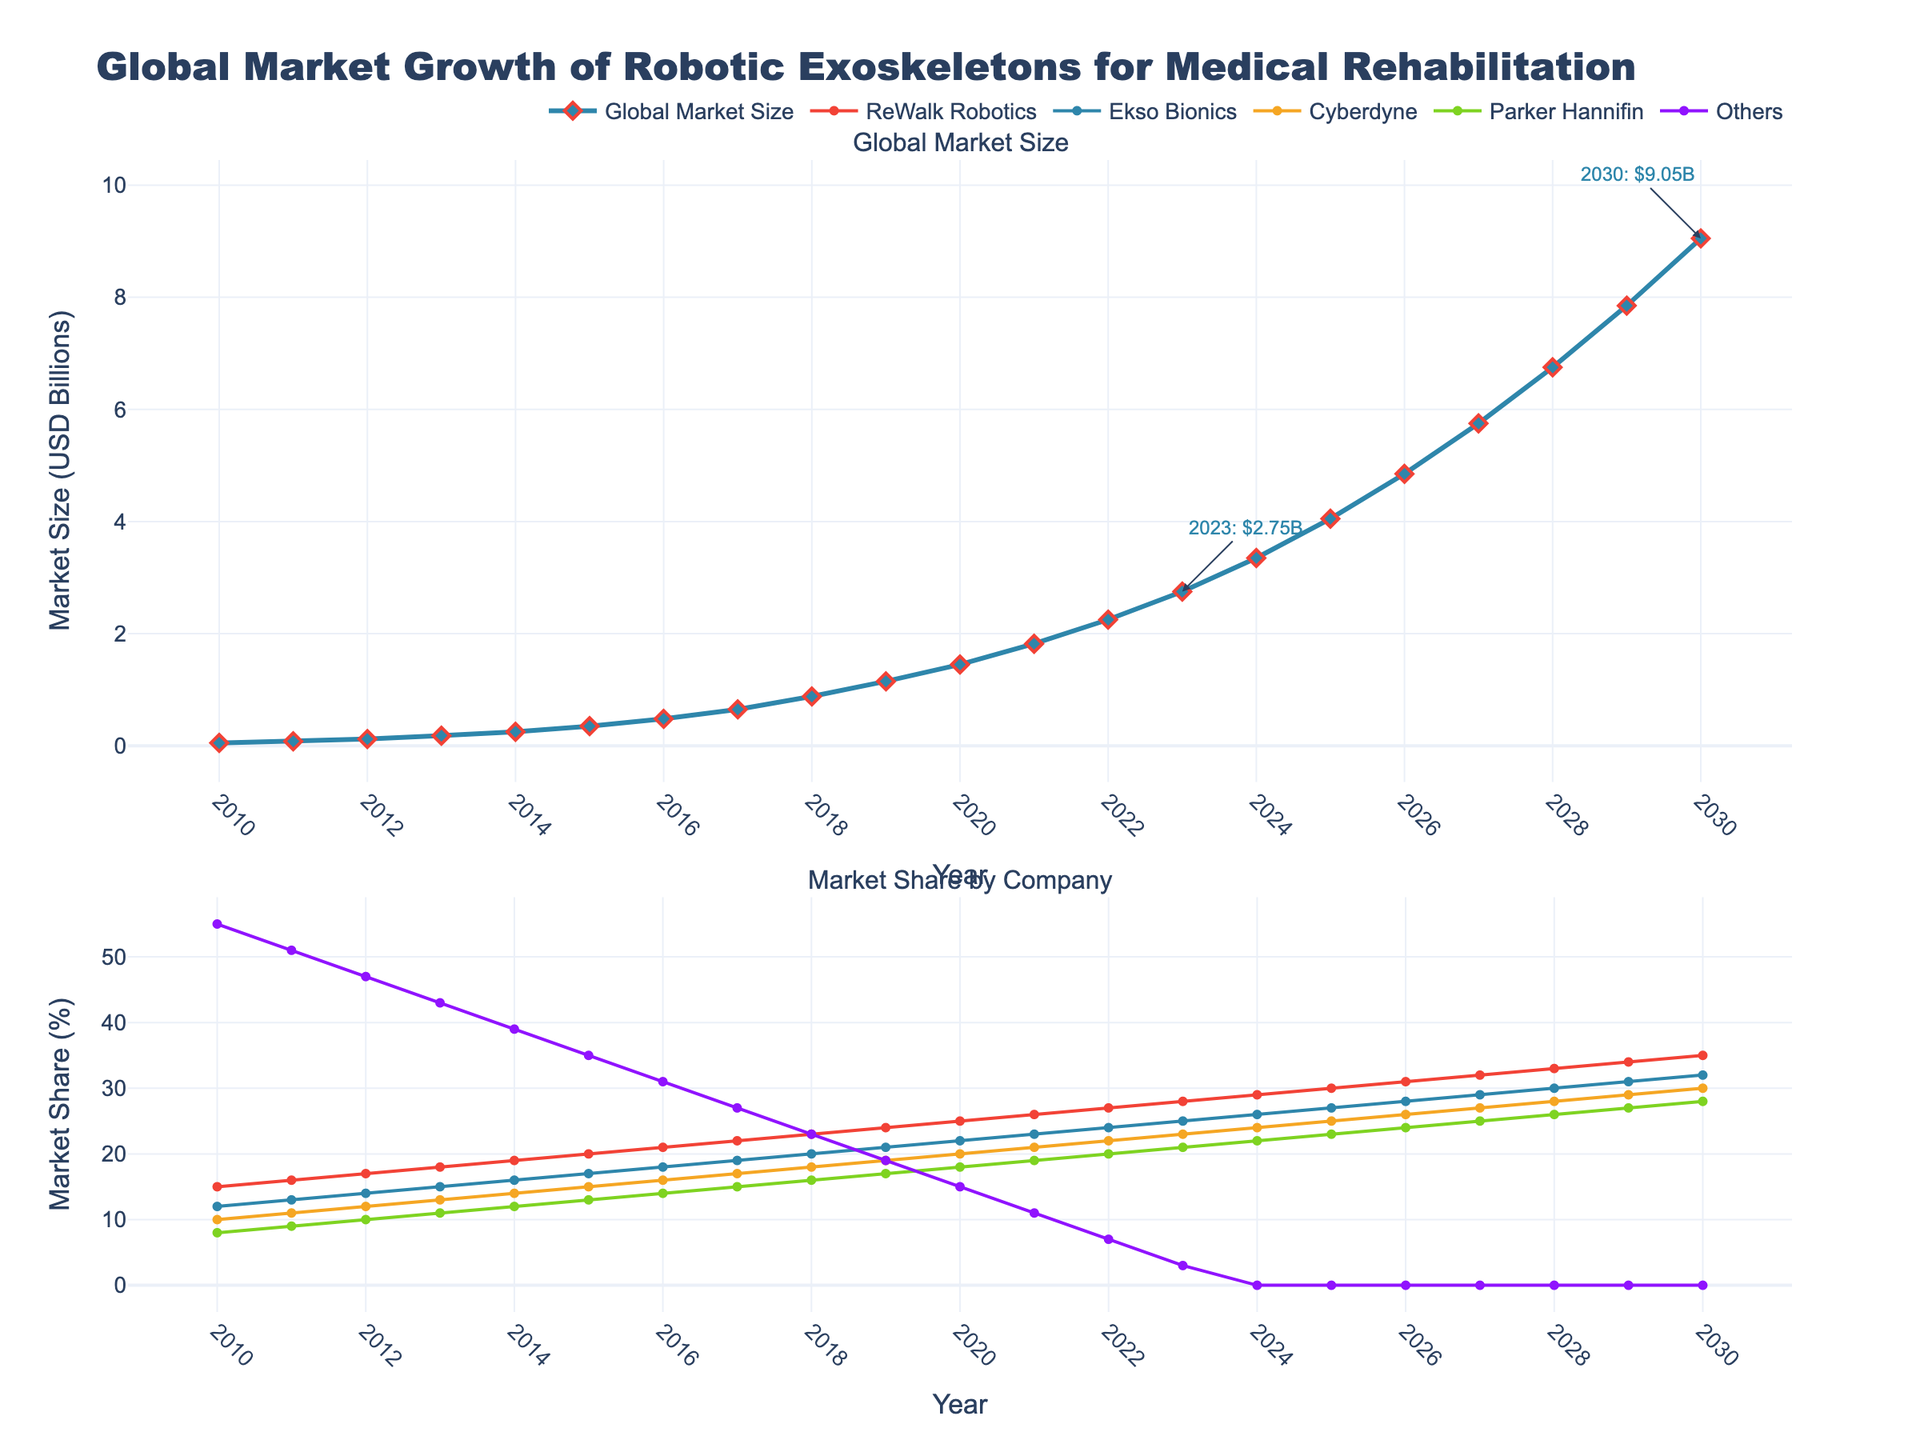What is the total market share of ReWalk Robotics and Cyberdyne in 2025? ReWalk Robotics has a market share of 30% and Cyberdyne has a market share of 25% in 2025. Summing these gives 30% + 25% = 55%
Answer: 55% Which company has the highest market share in 2020? In 2020, ReWalk Robotics has the highest market share at 25%, as it's the highest value among the companies listed for that year.
Answer: ReWalk Robotics How much did the global market size increase from 2010 to 2023? The market size in 2010 was 0.05 billion USD and in 2023 it was 2.75 billion USD. The increase is 2.75 - 0.05 = 2.70 billion USD.
Answer: 2.70 billion USD Compare the market share of Parker Hannifin in 2013 and 2023? In 2013, Parker Hannifin had a market share of 11%, and in 2023, the share increased to 21%. The increase is 21% - 11% = 10%.
Answer: Parker Hannifin's market share increased by 10% What is the trend in market share for Ekso Bionics from 2010 to 2023? Ekso Bionics' market share has shown a continuous increase from 12% in 2010 to 25% in 2023. This indicates a consistent growth trend over the years.
Answer: Consistent growth By how much does the global market size forecast for 2030 exceed the forecast for 2025? The forecasted market size for 2030 is 9.05 billion USD, while for 2025 it is 4.05 billion USD. The difference is 9.05 - 4.05 = 5 billion USD.
Answer: 5 billion USD What is the average annual growth rate of the global market size from 2020 to 2023? The global market size grows from 1.45 billion USD in 2020 to 2.75 billion USD in 2023, which is over 3 years. The growth rate can be approximated as (2.75 - 1.45) / 3 = 0.433 billion USD per year.
Answer: 0.433 billion USD per year How does the market share of "Others" change from 2010 to 2023? The market share of "Others" declines from 55% in 2010 to 3% in 2023, showing a significant decrease over the years.
Answer: Significant decrease Which company shows the second-highest market share in 2012? In 2012, Ekso Bionics shows the second-highest market share at 14%, following ReWalk Robotics at 17%.
Answer: Ekso Bionics 